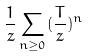<formula> <loc_0><loc_0><loc_500><loc_500>\frac { 1 } { z } \sum _ { n \geq 0 } ( \frac { T } { z } ) ^ { n }</formula> 